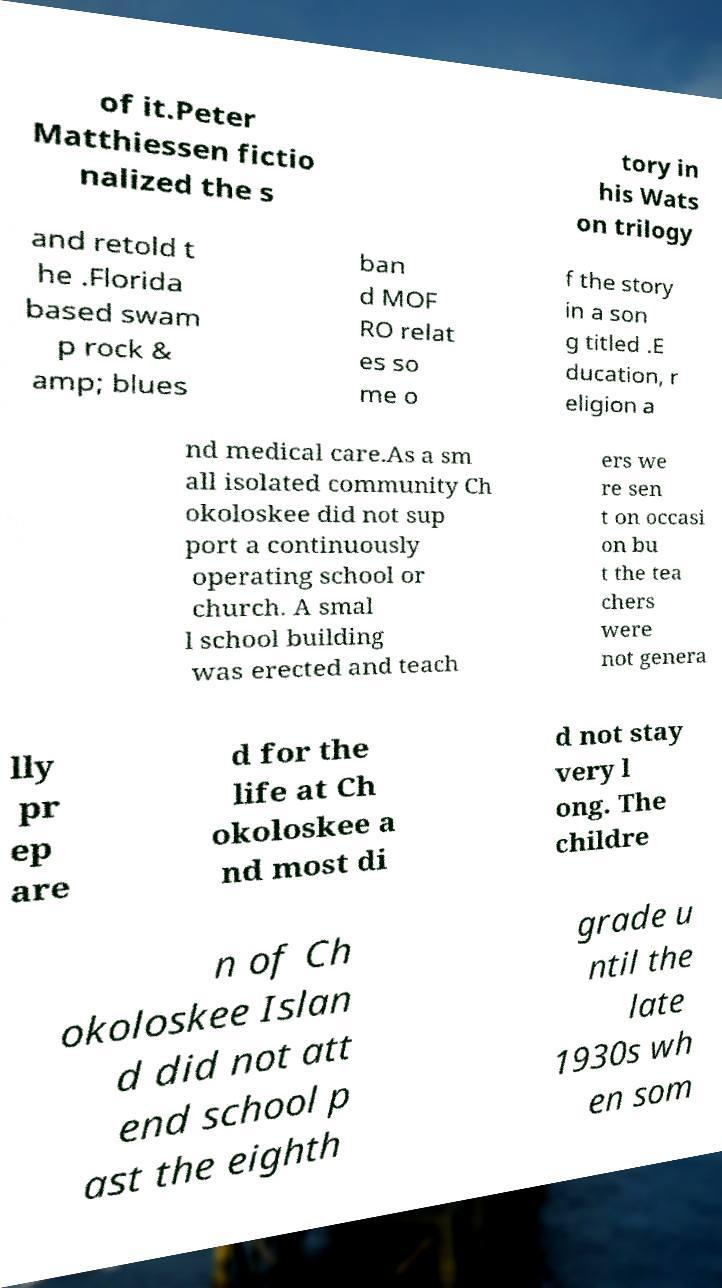Please read and relay the text visible in this image. What does it say? of it.Peter Matthiessen fictio nalized the s tory in his Wats on trilogy and retold t he .Florida based swam p rock & amp; blues ban d MOF RO relat es so me o f the story in a son g titled .E ducation, r eligion a nd medical care.As a sm all isolated community Ch okoloskee did not sup port a continuously operating school or church. A smal l school building was erected and teach ers we re sen t on occasi on bu t the tea chers were not genera lly pr ep are d for the life at Ch okoloskee a nd most di d not stay very l ong. The childre n of Ch okoloskee Islan d did not att end school p ast the eighth grade u ntil the late 1930s wh en som 